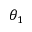<formula> <loc_0><loc_0><loc_500><loc_500>\theta _ { 1 }</formula> 